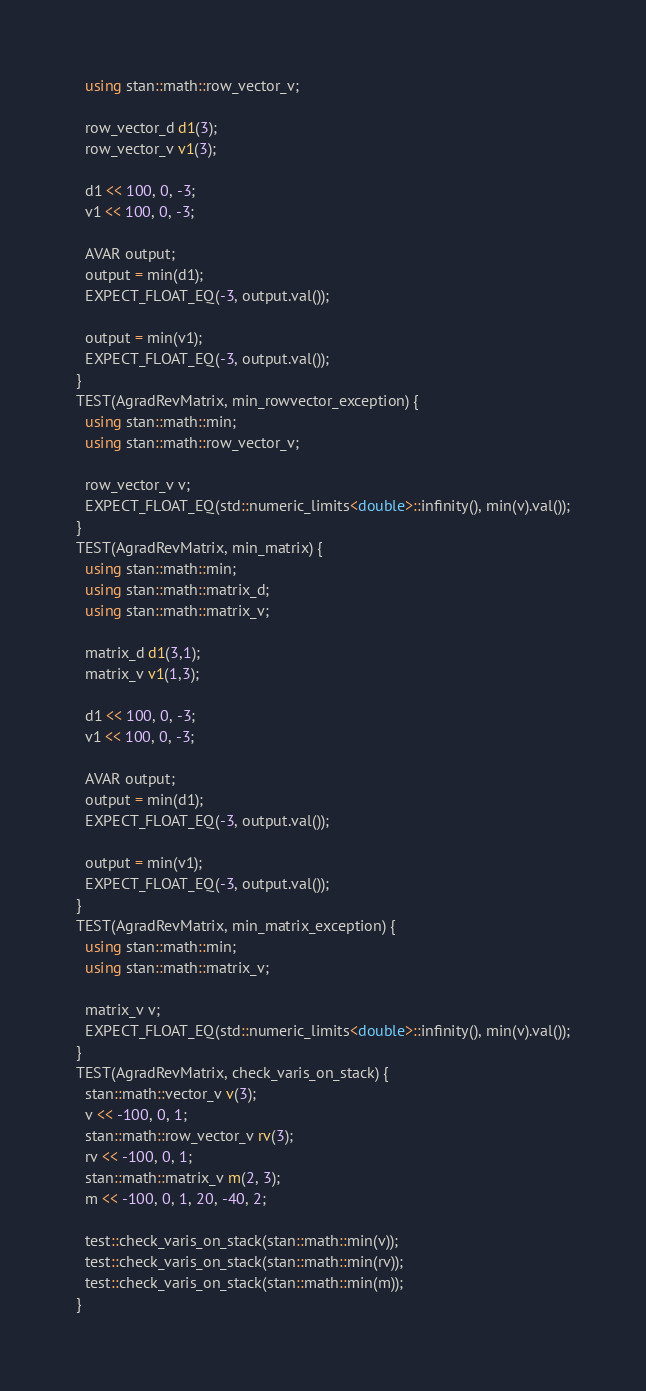Convert code to text. <code><loc_0><loc_0><loc_500><loc_500><_C++_>  using stan::math::row_vector_v;

  row_vector_d d1(3);
  row_vector_v v1(3);
  
  d1 << 100, 0, -3;
  v1 << 100, 0, -3;
  
  AVAR output;
  output = min(d1);
  EXPECT_FLOAT_EQ(-3, output.val());
                   
  output = min(v1);
  EXPECT_FLOAT_EQ(-3, output.val());
}
TEST(AgradRevMatrix, min_rowvector_exception) {
  using stan::math::min;
  using stan::math::row_vector_v;

  row_vector_v v;
  EXPECT_FLOAT_EQ(std::numeric_limits<double>::infinity(), min(v).val());
}
TEST(AgradRevMatrix, min_matrix) {
  using stan::math::min;
  using stan::math::matrix_d;
  using stan::math::matrix_v;
 
  matrix_d d1(3,1);
  matrix_v v1(1,3);
  
  d1 << 100, 0, -3;
  v1 << 100, 0, -3;
  
  AVAR output;
  output = min(d1);
  EXPECT_FLOAT_EQ(-3, output.val());
                   
  output = min(v1);
  EXPECT_FLOAT_EQ(-3, output.val());
}
TEST(AgradRevMatrix, min_matrix_exception) {
  using stan::math::min;
  using stan::math::matrix_v;

  matrix_v v;
  EXPECT_FLOAT_EQ(std::numeric_limits<double>::infinity(), min(v).val());
}
TEST(AgradRevMatrix, check_varis_on_stack) {
  stan::math::vector_v v(3);
  v << -100, 0, 1;
  stan::math::row_vector_v rv(3);
  rv << -100, 0, 1;
  stan::math::matrix_v m(2, 3);
  m << -100, 0, 1, 20, -40, 2;
  
  test::check_varis_on_stack(stan::math::min(v));
  test::check_varis_on_stack(stan::math::min(rv));
  test::check_varis_on_stack(stan::math::min(m));
}
</code> 